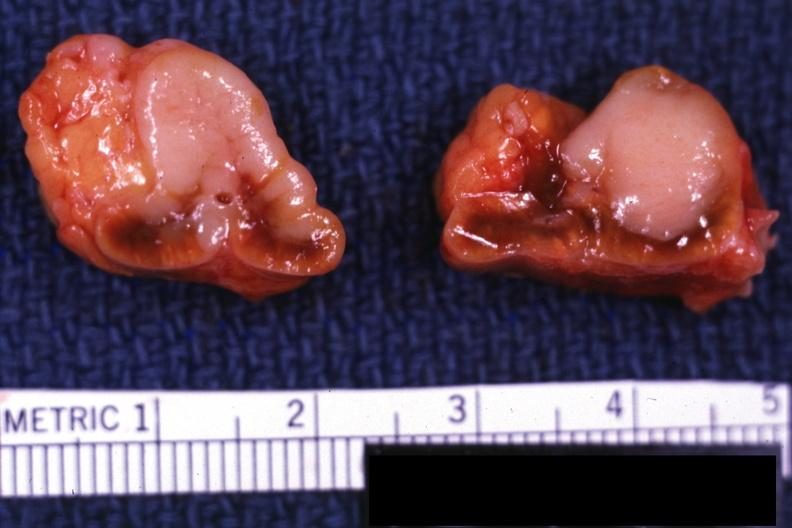does situs inversus show sectioned gland bilateral lesions excellent example?
Answer the question using a single word or phrase. No 